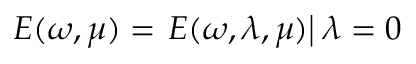<formula> <loc_0><loc_0><loc_500><loc_500>E ( \omega , \mu ) = E ( \omega , \lambda , \mu ) \right | \lambda = 0</formula> 